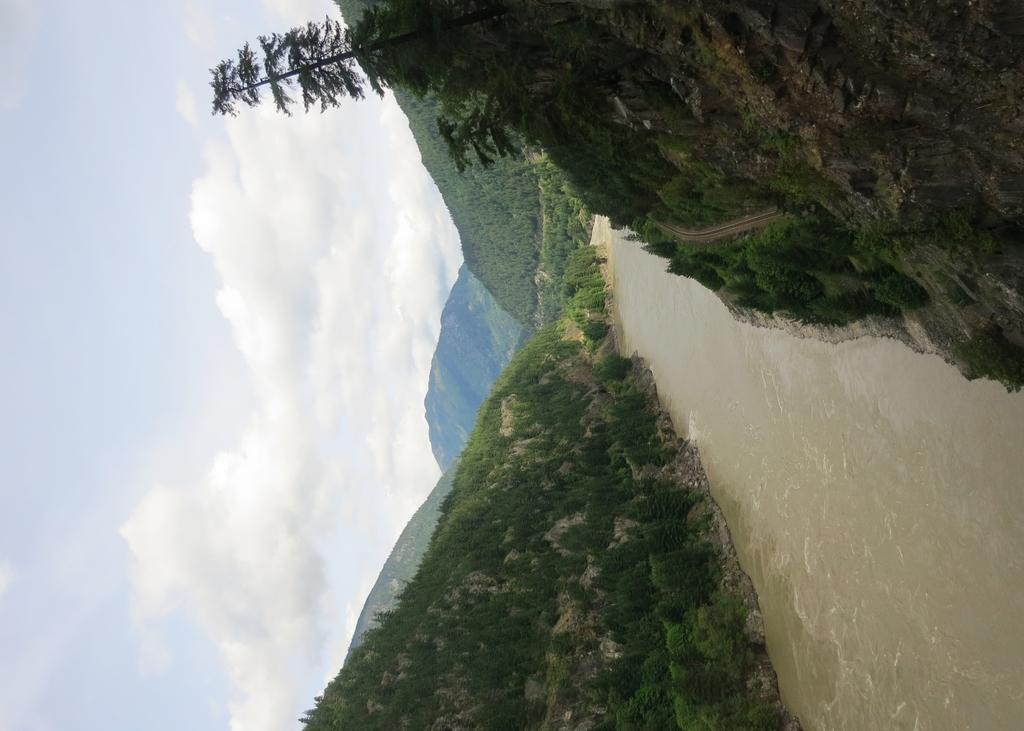What type of vegetation can be seen in the image? There are trees in the image. What is the color of the trees? The trees are green in color. What else is visible in the image besides the trees? There is water visible in the image. What is the color of the sky in the image? The sky is white in color. What is the health condition of the brother in the image? There is no brother present in the image, so it is not possible to determine their health condition. 